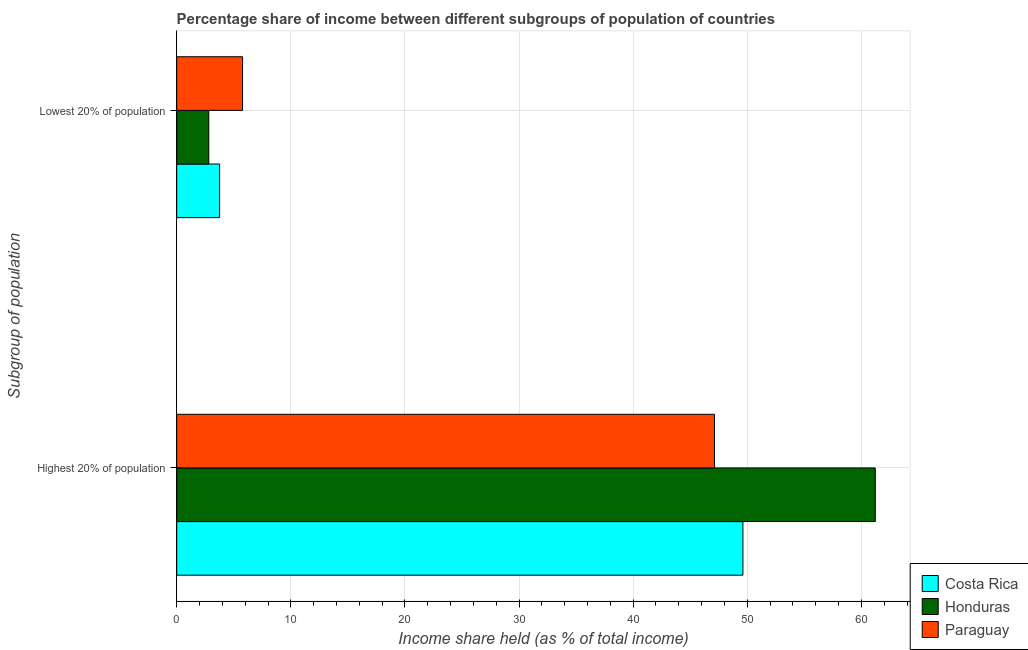How many different coloured bars are there?
Offer a terse response. 3. What is the label of the 2nd group of bars from the top?
Ensure brevity in your answer.  Highest 20% of population. What is the income share held by highest 20% of the population in Costa Rica?
Provide a short and direct response. 49.62. Across all countries, what is the maximum income share held by highest 20% of the population?
Make the answer very short. 61.22. Across all countries, what is the minimum income share held by lowest 20% of the population?
Your response must be concise. 2.81. In which country was the income share held by highest 20% of the population maximum?
Offer a very short reply. Honduras. In which country was the income share held by highest 20% of the population minimum?
Make the answer very short. Paraguay. What is the total income share held by lowest 20% of the population in the graph?
Provide a succinct answer. 12.34. What is the difference between the income share held by highest 20% of the population in Paraguay and that in Costa Rica?
Your response must be concise. -2.49. What is the difference between the income share held by lowest 20% of the population in Honduras and the income share held by highest 20% of the population in Costa Rica?
Provide a short and direct response. -46.81. What is the average income share held by lowest 20% of the population per country?
Provide a short and direct response. 4.11. What is the difference between the income share held by lowest 20% of the population and income share held by highest 20% of the population in Paraguay?
Your answer should be very brief. -41.36. What is the ratio of the income share held by lowest 20% of the population in Honduras to that in Paraguay?
Offer a very short reply. 0.49. Is the income share held by lowest 20% of the population in Costa Rica less than that in Paraguay?
Give a very brief answer. Yes. What does the 1st bar from the top in Lowest 20% of population represents?
Provide a short and direct response. Paraguay. What does the 2nd bar from the bottom in Lowest 20% of population represents?
Your answer should be compact. Honduras. Are the values on the major ticks of X-axis written in scientific E-notation?
Keep it short and to the point. No. How are the legend labels stacked?
Ensure brevity in your answer.  Vertical. What is the title of the graph?
Your answer should be compact. Percentage share of income between different subgroups of population of countries. What is the label or title of the X-axis?
Offer a terse response. Income share held (as % of total income). What is the label or title of the Y-axis?
Keep it short and to the point. Subgroup of population. What is the Income share held (as % of total income) in Costa Rica in Highest 20% of population?
Offer a terse response. 49.62. What is the Income share held (as % of total income) in Honduras in Highest 20% of population?
Keep it short and to the point. 61.22. What is the Income share held (as % of total income) in Paraguay in Highest 20% of population?
Your answer should be very brief. 47.13. What is the Income share held (as % of total income) in Costa Rica in Lowest 20% of population?
Offer a terse response. 3.76. What is the Income share held (as % of total income) in Honduras in Lowest 20% of population?
Provide a short and direct response. 2.81. What is the Income share held (as % of total income) in Paraguay in Lowest 20% of population?
Offer a very short reply. 5.77. Across all Subgroup of population, what is the maximum Income share held (as % of total income) in Costa Rica?
Your answer should be compact. 49.62. Across all Subgroup of population, what is the maximum Income share held (as % of total income) in Honduras?
Your answer should be compact. 61.22. Across all Subgroup of population, what is the maximum Income share held (as % of total income) in Paraguay?
Give a very brief answer. 47.13. Across all Subgroup of population, what is the minimum Income share held (as % of total income) in Costa Rica?
Keep it short and to the point. 3.76. Across all Subgroup of population, what is the minimum Income share held (as % of total income) in Honduras?
Your answer should be compact. 2.81. Across all Subgroup of population, what is the minimum Income share held (as % of total income) of Paraguay?
Your answer should be very brief. 5.77. What is the total Income share held (as % of total income) in Costa Rica in the graph?
Make the answer very short. 53.38. What is the total Income share held (as % of total income) of Honduras in the graph?
Offer a terse response. 64.03. What is the total Income share held (as % of total income) of Paraguay in the graph?
Offer a terse response. 52.9. What is the difference between the Income share held (as % of total income) of Costa Rica in Highest 20% of population and that in Lowest 20% of population?
Offer a terse response. 45.86. What is the difference between the Income share held (as % of total income) in Honduras in Highest 20% of population and that in Lowest 20% of population?
Your answer should be compact. 58.41. What is the difference between the Income share held (as % of total income) in Paraguay in Highest 20% of population and that in Lowest 20% of population?
Provide a succinct answer. 41.36. What is the difference between the Income share held (as % of total income) in Costa Rica in Highest 20% of population and the Income share held (as % of total income) in Honduras in Lowest 20% of population?
Ensure brevity in your answer.  46.81. What is the difference between the Income share held (as % of total income) in Costa Rica in Highest 20% of population and the Income share held (as % of total income) in Paraguay in Lowest 20% of population?
Give a very brief answer. 43.85. What is the difference between the Income share held (as % of total income) of Honduras in Highest 20% of population and the Income share held (as % of total income) of Paraguay in Lowest 20% of population?
Ensure brevity in your answer.  55.45. What is the average Income share held (as % of total income) of Costa Rica per Subgroup of population?
Your answer should be compact. 26.69. What is the average Income share held (as % of total income) of Honduras per Subgroup of population?
Make the answer very short. 32.02. What is the average Income share held (as % of total income) of Paraguay per Subgroup of population?
Ensure brevity in your answer.  26.45. What is the difference between the Income share held (as % of total income) in Costa Rica and Income share held (as % of total income) in Honduras in Highest 20% of population?
Offer a very short reply. -11.6. What is the difference between the Income share held (as % of total income) in Costa Rica and Income share held (as % of total income) in Paraguay in Highest 20% of population?
Make the answer very short. 2.49. What is the difference between the Income share held (as % of total income) in Honduras and Income share held (as % of total income) in Paraguay in Highest 20% of population?
Offer a very short reply. 14.09. What is the difference between the Income share held (as % of total income) in Costa Rica and Income share held (as % of total income) in Honduras in Lowest 20% of population?
Your answer should be very brief. 0.95. What is the difference between the Income share held (as % of total income) of Costa Rica and Income share held (as % of total income) of Paraguay in Lowest 20% of population?
Provide a succinct answer. -2.01. What is the difference between the Income share held (as % of total income) of Honduras and Income share held (as % of total income) of Paraguay in Lowest 20% of population?
Ensure brevity in your answer.  -2.96. What is the ratio of the Income share held (as % of total income) of Costa Rica in Highest 20% of population to that in Lowest 20% of population?
Offer a terse response. 13.2. What is the ratio of the Income share held (as % of total income) of Honduras in Highest 20% of population to that in Lowest 20% of population?
Make the answer very short. 21.79. What is the ratio of the Income share held (as % of total income) in Paraguay in Highest 20% of population to that in Lowest 20% of population?
Offer a very short reply. 8.17. What is the difference between the highest and the second highest Income share held (as % of total income) of Costa Rica?
Give a very brief answer. 45.86. What is the difference between the highest and the second highest Income share held (as % of total income) of Honduras?
Provide a succinct answer. 58.41. What is the difference between the highest and the second highest Income share held (as % of total income) in Paraguay?
Make the answer very short. 41.36. What is the difference between the highest and the lowest Income share held (as % of total income) in Costa Rica?
Offer a very short reply. 45.86. What is the difference between the highest and the lowest Income share held (as % of total income) in Honduras?
Your response must be concise. 58.41. What is the difference between the highest and the lowest Income share held (as % of total income) in Paraguay?
Ensure brevity in your answer.  41.36. 